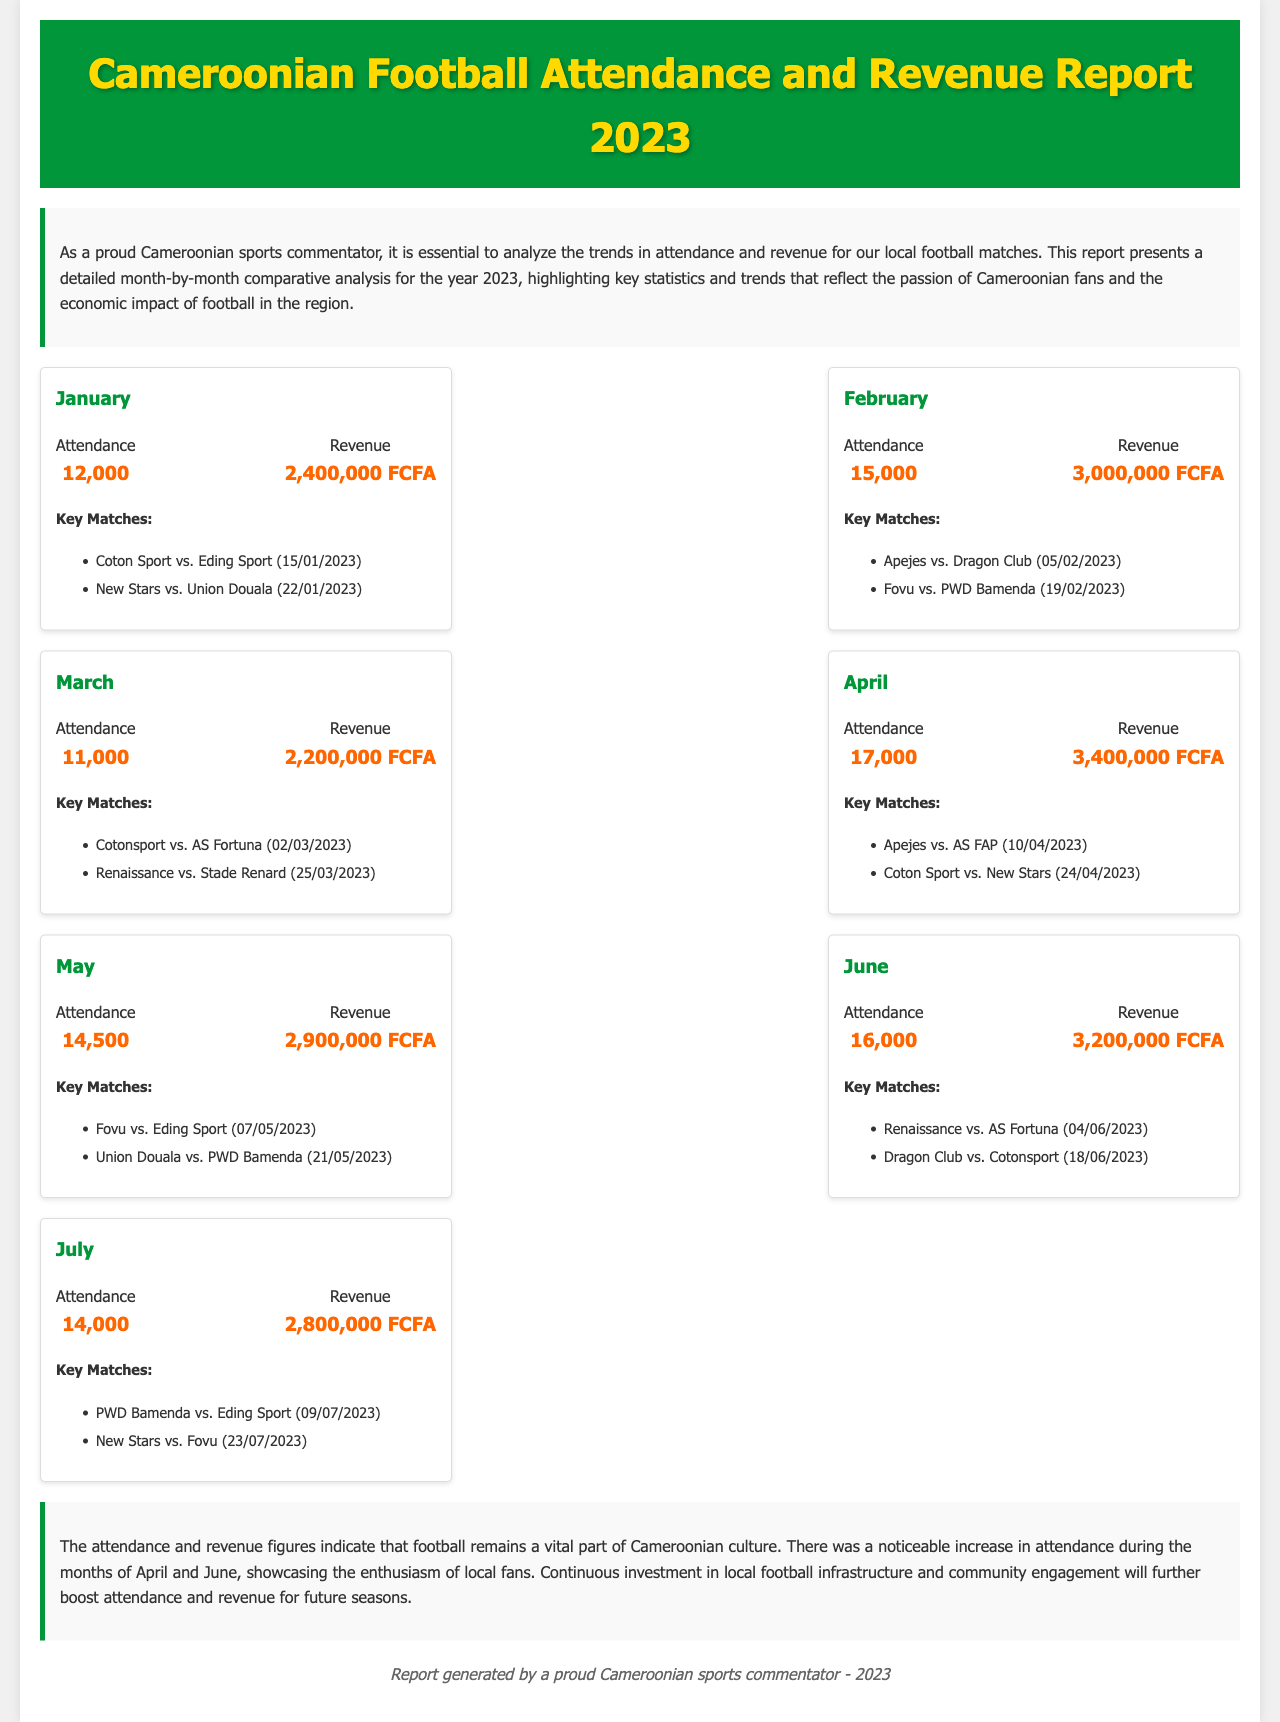What was the attendance in April? The attendance in April is specified in the document as 17,000.
Answer: 17,000 What is the revenue for February? The revenue for February is listed as 3,000,000 FCFA in the report.
Answer: 3,000,000 FCFA Which team played against Eding Sport in May? The document states that Fovu played against Eding Sport on 07/05/2023.
Answer: Fovu What month had the highest attendance? By comparing the attendance figures across all months, April shows the highest attendance at 17,000.
Answer: April How many key matches are listed for January? The report mentions two key matches played during January.
Answer: 2 What is the total revenue from January to July? The total revenue is calculated by adding the revenue from each month listed from January to July.
Answer: 16,700,000 FCFA Which month had a decrease in attendance compared to the previous month? March had a decrease in attendance from February (15,000 to 11,000).
Answer: March What is the theme of the introductory paragraph? The introduction emphasizes the importance of analyzing attendance and revenue trends in local football matches.
Answer: Analysis of trends 